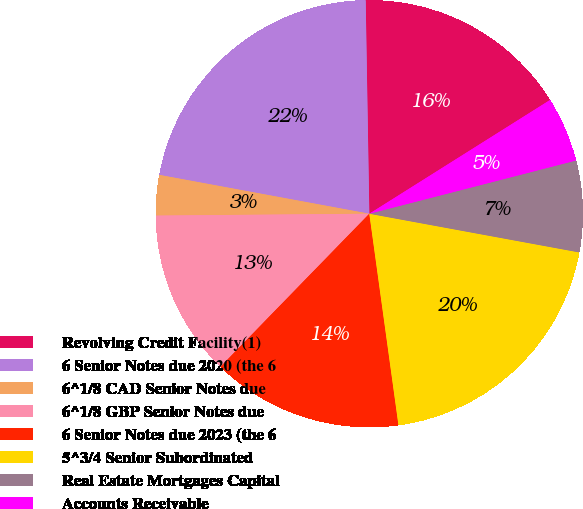<chart> <loc_0><loc_0><loc_500><loc_500><pie_chart><fcel>Revolving Credit Facility(1)<fcel>6 Senior Notes due 2020 (the 6<fcel>6^1/8 CAD Senior Notes due<fcel>6^1/8 GBP Senior Notes due<fcel>6 Senior Notes due 2023 (the 6<fcel>5^3/4 Senior Subordinated<fcel>Real Estate Mortgages Capital<fcel>Accounts Receivable<nl><fcel>16.33%<fcel>21.82%<fcel>3.05%<fcel>12.58%<fcel>14.46%<fcel>19.92%<fcel>6.91%<fcel>4.93%<nl></chart> 